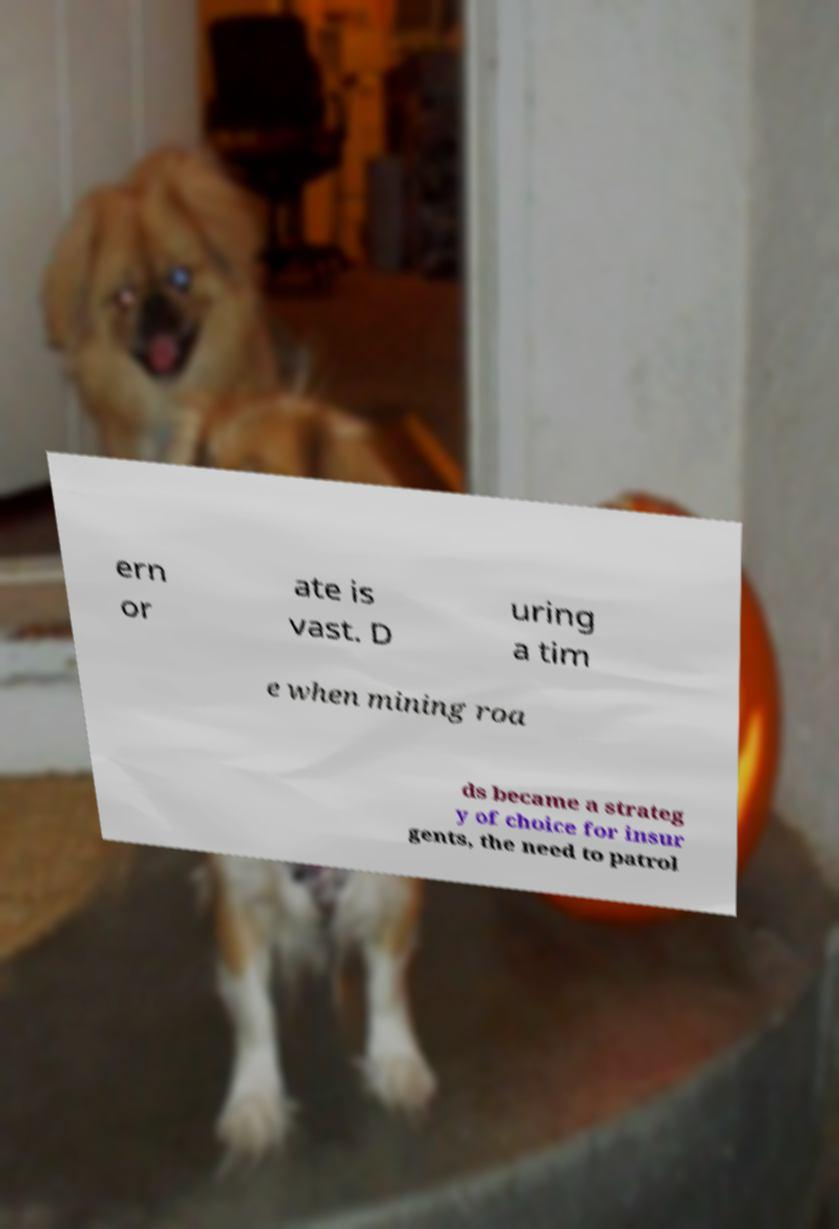Could you extract and type out the text from this image? ern or ate is vast. D uring a tim e when mining roa ds became a strateg y of choice for insur gents, the need to patrol 